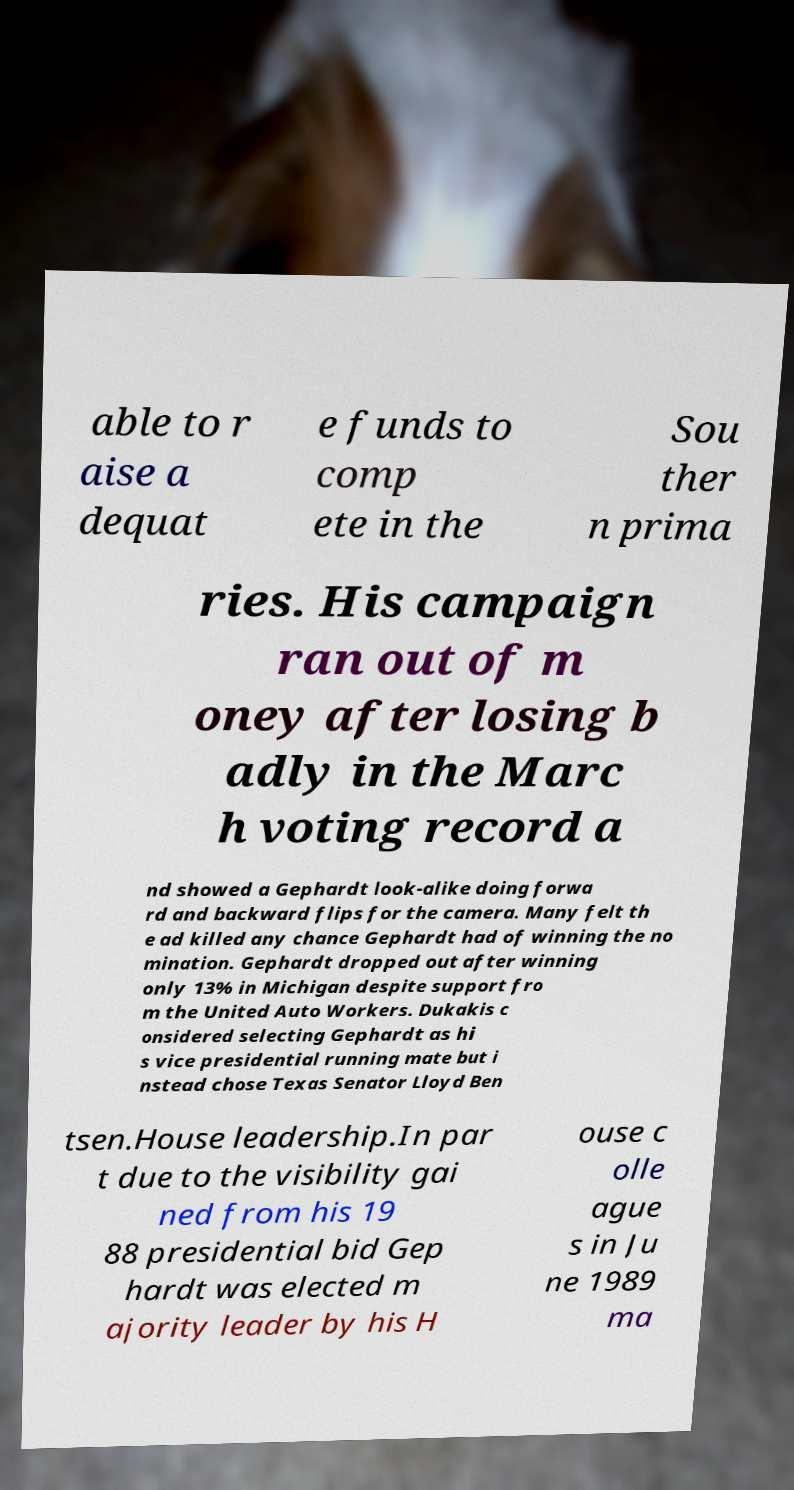There's text embedded in this image that I need extracted. Can you transcribe it verbatim? able to r aise a dequat e funds to comp ete in the Sou ther n prima ries. His campaign ran out of m oney after losing b adly in the Marc h voting record a nd showed a Gephardt look-alike doing forwa rd and backward flips for the camera. Many felt th e ad killed any chance Gephardt had of winning the no mination. Gephardt dropped out after winning only 13% in Michigan despite support fro m the United Auto Workers. Dukakis c onsidered selecting Gephardt as hi s vice presidential running mate but i nstead chose Texas Senator Lloyd Ben tsen.House leadership.In par t due to the visibility gai ned from his 19 88 presidential bid Gep hardt was elected m ajority leader by his H ouse c olle ague s in Ju ne 1989 ma 